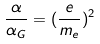Convert formula to latex. <formula><loc_0><loc_0><loc_500><loc_500>\frac { \alpha } { \alpha _ { G } } = ( \frac { e } { m _ { e } } ) ^ { 2 }</formula> 